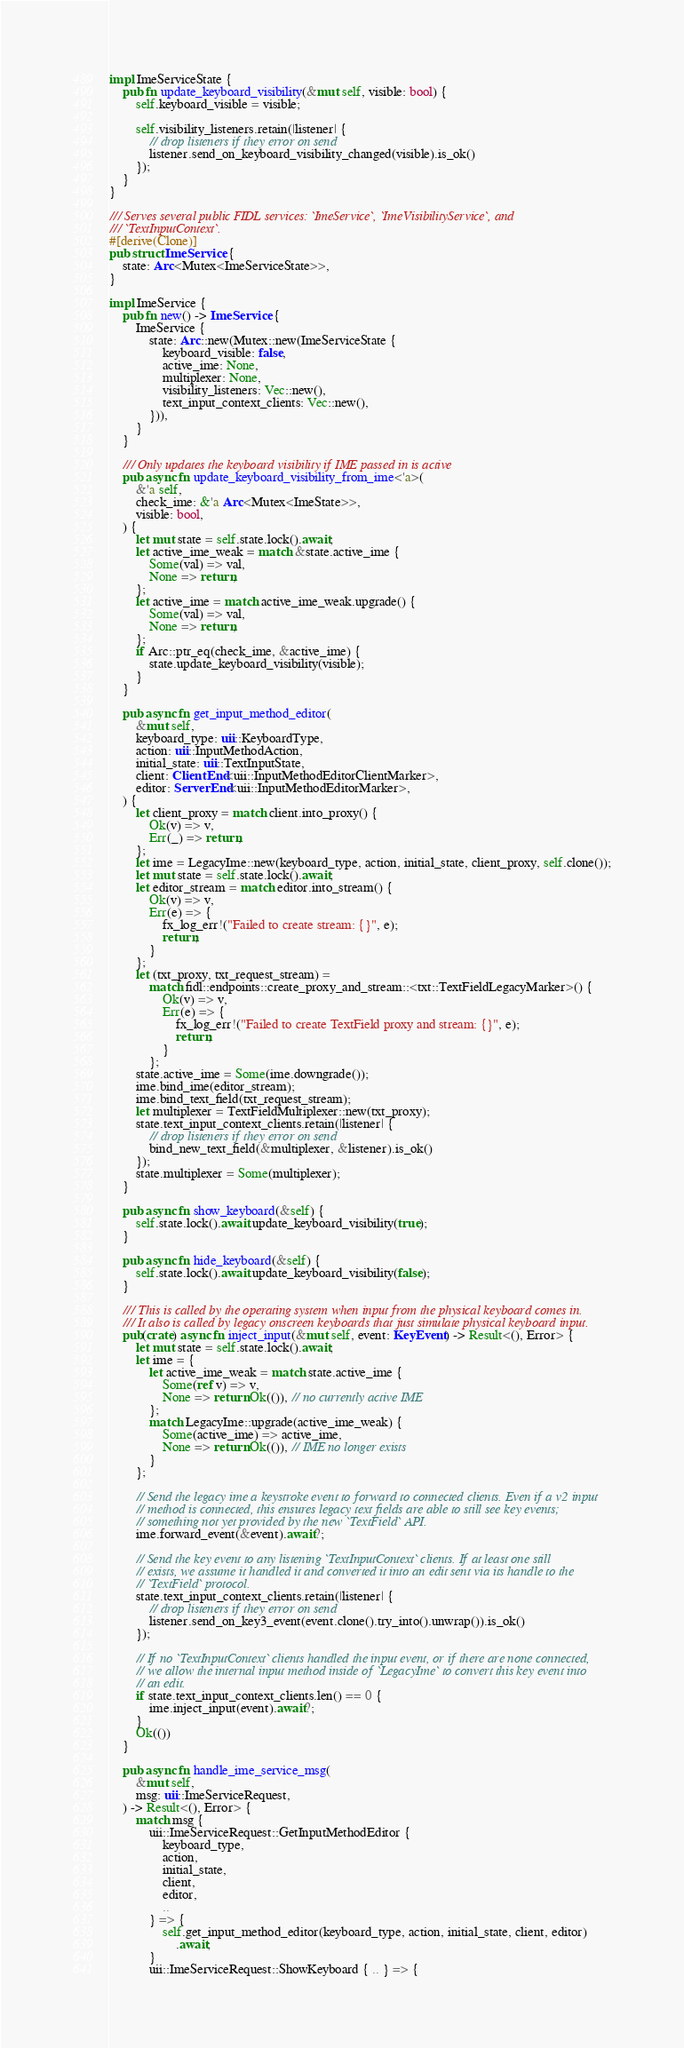Convert code to text. <code><loc_0><loc_0><loc_500><loc_500><_Rust_>impl ImeServiceState {
    pub fn update_keyboard_visibility(&mut self, visible: bool) {
        self.keyboard_visible = visible;

        self.visibility_listeners.retain(|listener| {
            // drop listeners if they error on send
            listener.send_on_keyboard_visibility_changed(visible).is_ok()
        });
    }
}

/// Serves several public FIDL services: `ImeService`, `ImeVisibilityService`, and
/// `TextInputContext`.
#[derive(Clone)]
pub struct ImeService {
    state: Arc<Mutex<ImeServiceState>>,
}

impl ImeService {
    pub fn new() -> ImeService {
        ImeService {
            state: Arc::new(Mutex::new(ImeServiceState {
                keyboard_visible: false,
                active_ime: None,
                multiplexer: None,
                visibility_listeners: Vec::new(),
                text_input_context_clients: Vec::new(),
            })),
        }
    }

    /// Only updates the keyboard visibility if IME passed in is active
    pub async fn update_keyboard_visibility_from_ime<'a>(
        &'a self,
        check_ime: &'a Arc<Mutex<ImeState>>,
        visible: bool,
    ) {
        let mut state = self.state.lock().await;
        let active_ime_weak = match &state.active_ime {
            Some(val) => val,
            None => return,
        };
        let active_ime = match active_ime_weak.upgrade() {
            Some(val) => val,
            None => return,
        };
        if Arc::ptr_eq(check_ime, &active_ime) {
            state.update_keyboard_visibility(visible);
        }
    }

    pub async fn get_input_method_editor(
        &mut self,
        keyboard_type: uii::KeyboardType,
        action: uii::InputMethodAction,
        initial_state: uii::TextInputState,
        client: ClientEnd<uii::InputMethodEditorClientMarker>,
        editor: ServerEnd<uii::InputMethodEditorMarker>,
    ) {
        let client_proxy = match client.into_proxy() {
            Ok(v) => v,
            Err(_) => return,
        };
        let ime = LegacyIme::new(keyboard_type, action, initial_state, client_proxy, self.clone());
        let mut state = self.state.lock().await;
        let editor_stream = match editor.into_stream() {
            Ok(v) => v,
            Err(e) => {
                fx_log_err!("Failed to create stream: {}", e);
                return;
            }
        };
        let (txt_proxy, txt_request_stream) =
            match fidl::endpoints::create_proxy_and_stream::<txt::TextFieldLegacyMarker>() {
                Ok(v) => v,
                Err(e) => {
                    fx_log_err!("Failed to create TextField proxy and stream: {}", e);
                    return;
                }
            };
        state.active_ime = Some(ime.downgrade());
        ime.bind_ime(editor_stream);
        ime.bind_text_field(txt_request_stream);
        let multiplexer = TextFieldMultiplexer::new(txt_proxy);
        state.text_input_context_clients.retain(|listener| {
            // drop listeners if they error on send
            bind_new_text_field(&multiplexer, &listener).is_ok()
        });
        state.multiplexer = Some(multiplexer);
    }

    pub async fn show_keyboard(&self) {
        self.state.lock().await.update_keyboard_visibility(true);
    }

    pub async fn hide_keyboard(&self) {
        self.state.lock().await.update_keyboard_visibility(false);
    }

    /// This is called by the operating system when input from the physical keyboard comes in.
    /// It also is called by legacy onscreen keyboards that just simulate physical keyboard input.
    pub(crate) async fn inject_input(&mut self, event: KeyEvent) -> Result<(), Error> {
        let mut state = self.state.lock().await;
        let ime = {
            let active_ime_weak = match state.active_ime {
                Some(ref v) => v,
                None => return Ok(()), // no currently active IME
            };
            match LegacyIme::upgrade(active_ime_weak) {
                Some(active_ime) => active_ime,
                None => return Ok(()), // IME no longer exists
            }
        };

        // Send the legacy ime a keystroke event to forward to connected clients. Even if a v2 input
        // method is connected, this ensures legacy text fields are able to still see key events;
        // something not yet provided by the new `TextField` API.
        ime.forward_event(&event).await?;

        // Send the key event to any listening `TextInputContext` clients. If at least one still
        // exists, we assume it handled it and converted it into an edit sent via its handle to the
        // `TextField` protocol.
        state.text_input_context_clients.retain(|listener| {
            // drop listeners if they error on send
            listener.send_on_key3_event(event.clone().try_into().unwrap()).is_ok()
        });

        // If no `TextInputContext` clients handled the input event, or if there are none connected,
        // we allow the internal input method inside of `LegacyIme` to convert this key event into
        // an edit.
        if state.text_input_context_clients.len() == 0 {
            ime.inject_input(event).await?;
        }
        Ok(())
    }

    pub async fn handle_ime_service_msg(
        &mut self,
        msg: uii::ImeServiceRequest,
    ) -> Result<(), Error> {
        match msg {
            uii::ImeServiceRequest::GetInputMethodEditor {
                keyboard_type,
                action,
                initial_state,
                client,
                editor,
                ..
            } => {
                self.get_input_method_editor(keyboard_type, action, initial_state, client, editor)
                    .await;
            }
            uii::ImeServiceRequest::ShowKeyboard { .. } => {</code> 